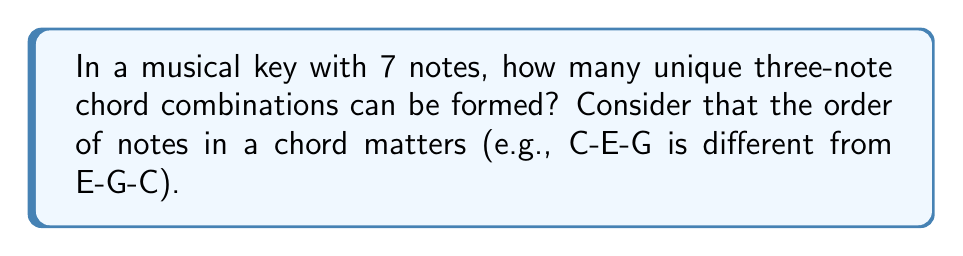Can you answer this question? Let's approach this step-by-step:

1) First, we need to understand that this is a permutation problem. We are selecting 3 notes from 7, and the order matters.

2) The formula for permutation is:

   $P(n,r) = \frac{n!}{(n-r)!}$

   Where $n$ is the total number of items to choose from, and $r$ is the number of items being chosen.

3) In this case, $n = 7$ (total notes in the key) and $r = 3$ (notes in each chord).

4) Plugging these values into our formula:

   $P(7,3) = \frac{7!}{(7-3)!} = \frac{7!}{4!}$

5) Let's calculate this:
   
   $$\frac{7!}{4!} = \frac{7 \times 6 \times 5 \times 4!}{4!} = 7 \times 6 \times 5 = 210$$

6) Therefore, there are 210 possible three-note chord combinations in a key with 7 notes.

This large number of combinations explains why musical directors, like our retired choir director, have so many options when arranging harmonies for their choirs!
Answer: 210 possible three-note chord combinations 